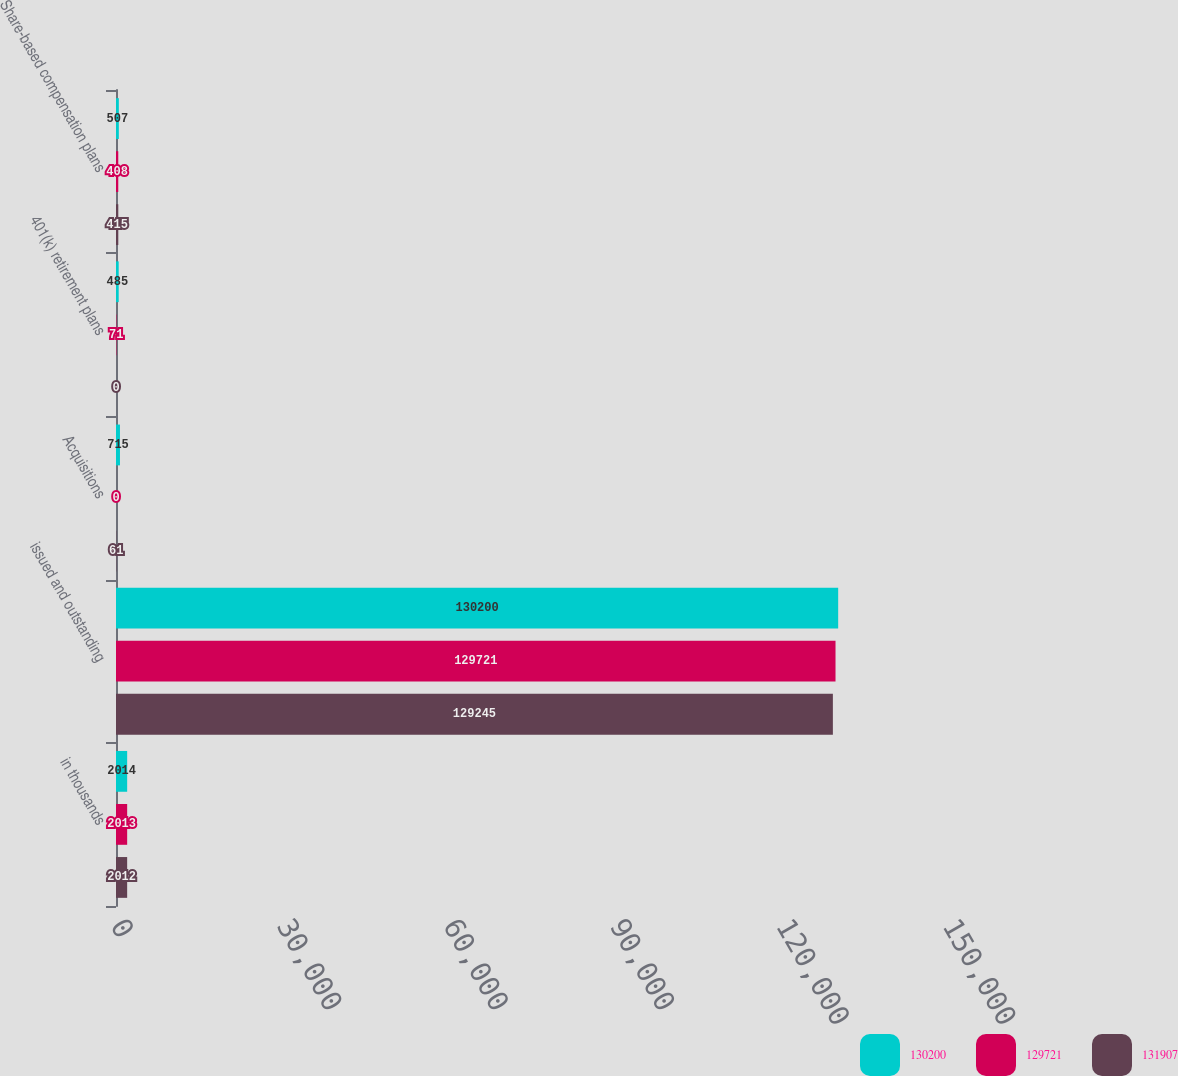Convert chart to OTSL. <chart><loc_0><loc_0><loc_500><loc_500><stacked_bar_chart><ecel><fcel>in thousands<fcel>issued and outstanding<fcel>Acquisitions<fcel>401(k) retirement plans<fcel>Share-based compensation plans<nl><fcel>130200<fcel>2014<fcel>130200<fcel>715<fcel>485<fcel>507<nl><fcel>129721<fcel>2013<fcel>129721<fcel>0<fcel>71<fcel>408<nl><fcel>131907<fcel>2012<fcel>129245<fcel>61<fcel>0<fcel>415<nl></chart> 